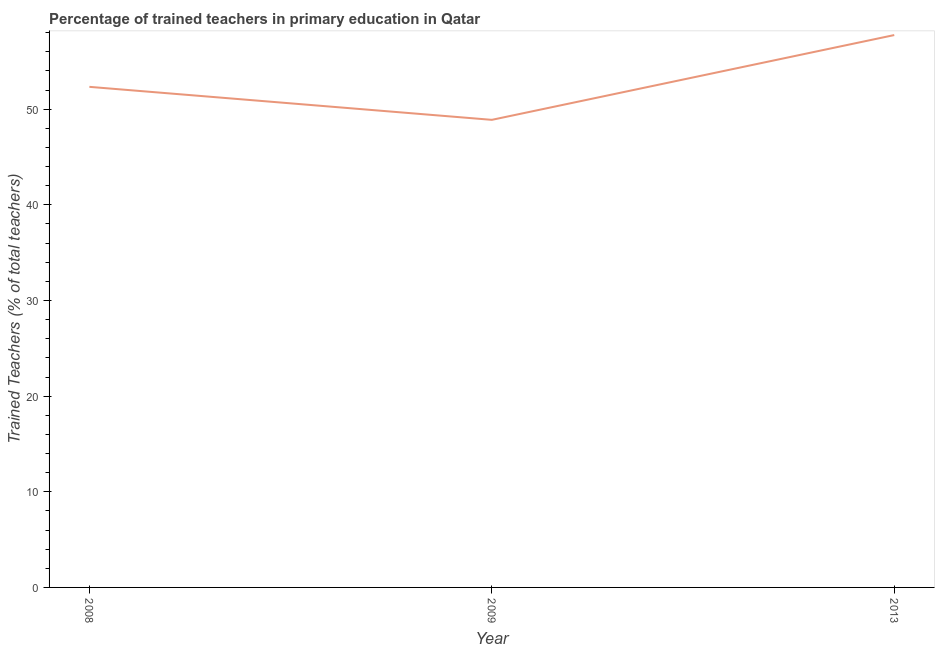What is the percentage of trained teachers in 2009?
Keep it short and to the point. 48.89. Across all years, what is the maximum percentage of trained teachers?
Your answer should be very brief. 57.75. Across all years, what is the minimum percentage of trained teachers?
Your response must be concise. 48.89. In which year was the percentage of trained teachers minimum?
Give a very brief answer. 2009. What is the sum of the percentage of trained teachers?
Keep it short and to the point. 158.97. What is the difference between the percentage of trained teachers in 2008 and 2013?
Offer a terse response. -5.41. What is the average percentage of trained teachers per year?
Your answer should be very brief. 52.99. What is the median percentage of trained teachers?
Offer a very short reply. 52.34. In how many years, is the percentage of trained teachers greater than 52 %?
Give a very brief answer. 2. Do a majority of the years between 2013 and 2009 (inclusive) have percentage of trained teachers greater than 44 %?
Your answer should be compact. No. What is the ratio of the percentage of trained teachers in 2009 to that in 2013?
Ensure brevity in your answer.  0.85. Is the percentage of trained teachers in 2008 less than that in 2013?
Ensure brevity in your answer.  Yes. What is the difference between the highest and the second highest percentage of trained teachers?
Keep it short and to the point. 5.41. Is the sum of the percentage of trained teachers in 2008 and 2009 greater than the maximum percentage of trained teachers across all years?
Give a very brief answer. Yes. What is the difference between the highest and the lowest percentage of trained teachers?
Offer a terse response. 8.86. In how many years, is the percentage of trained teachers greater than the average percentage of trained teachers taken over all years?
Your answer should be very brief. 1. Does the percentage of trained teachers monotonically increase over the years?
Your answer should be very brief. No. How many lines are there?
Provide a short and direct response. 1. How many years are there in the graph?
Your answer should be compact. 3. What is the difference between two consecutive major ticks on the Y-axis?
Your answer should be compact. 10. What is the title of the graph?
Keep it short and to the point. Percentage of trained teachers in primary education in Qatar. What is the label or title of the X-axis?
Your response must be concise. Year. What is the label or title of the Y-axis?
Provide a short and direct response. Trained Teachers (% of total teachers). What is the Trained Teachers (% of total teachers) in 2008?
Your response must be concise. 52.34. What is the Trained Teachers (% of total teachers) of 2009?
Offer a very short reply. 48.89. What is the Trained Teachers (% of total teachers) in 2013?
Ensure brevity in your answer.  57.75. What is the difference between the Trained Teachers (% of total teachers) in 2008 and 2009?
Provide a short and direct response. 3.45. What is the difference between the Trained Teachers (% of total teachers) in 2008 and 2013?
Provide a short and direct response. -5.41. What is the difference between the Trained Teachers (% of total teachers) in 2009 and 2013?
Your answer should be very brief. -8.86. What is the ratio of the Trained Teachers (% of total teachers) in 2008 to that in 2009?
Your response must be concise. 1.07. What is the ratio of the Trained Teachers (% of total teachers) in 2008 to that in 2013?
Offer a very short reply. 0.91. What is the ratio of the Trained Teachers (% of total teachers) in 2009 to that in 2013?
Keep it short and to the point. 0.85. 